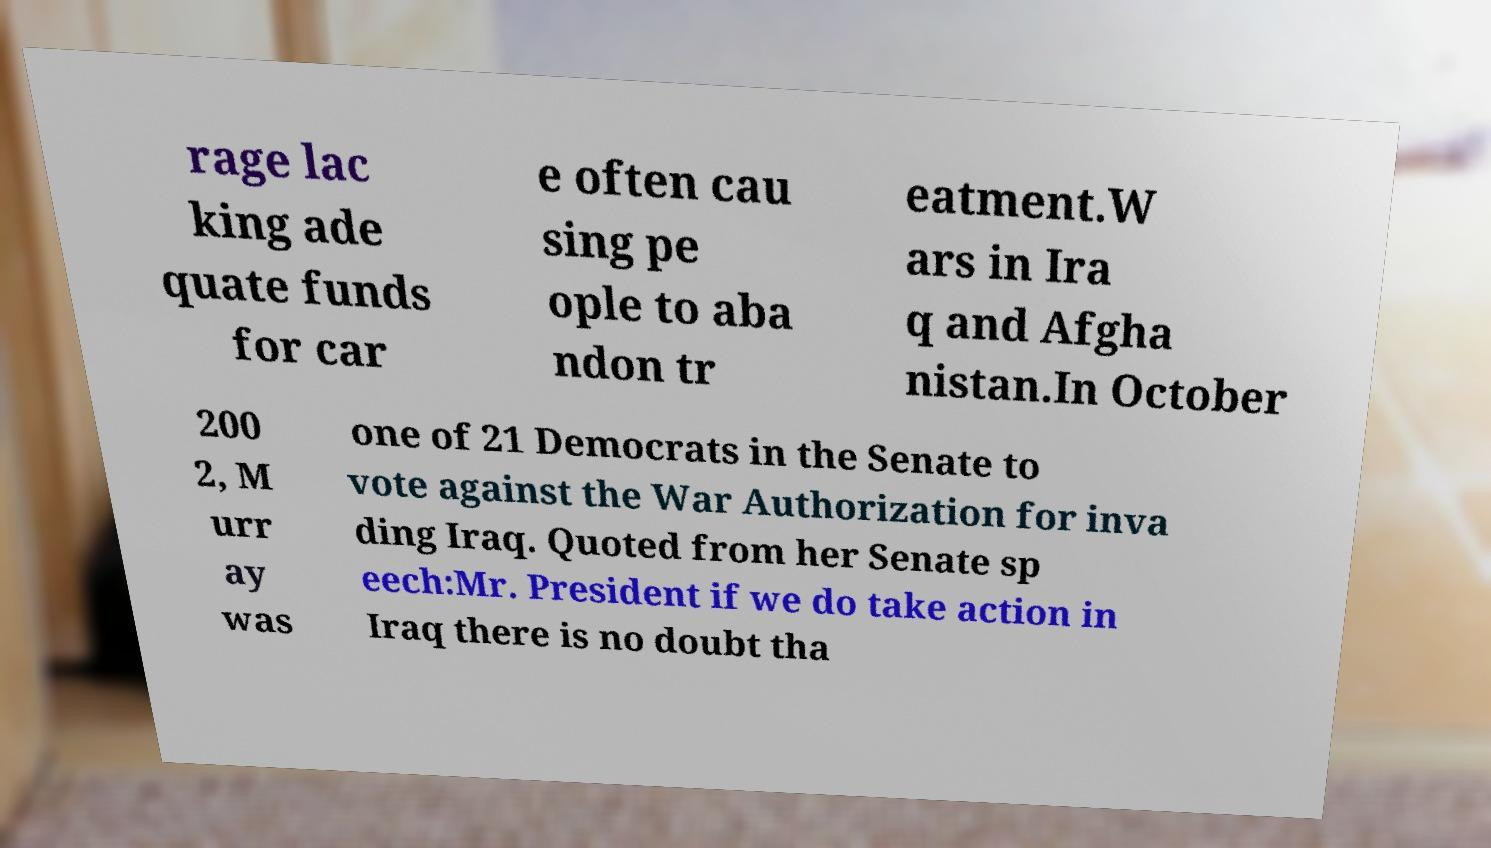What messages or text are displayed in this image? I need them in a readable, typed format. rage lac king ade quate funds for car e often cau sing pe ople to aba ndon tr eatment.W ars in Ira q and Afgha nistan.In October 200 2, M urr ay was one of 21 Democrats in the Senate to vote against the War Authorization for inva ding Iraq. Quoted from her Senate sp eech:Mr. President if we do take action in Iraq there is no doubt tha 